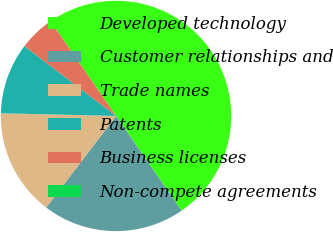<chart> <loc_0><loc_0><loc_500><loc_500><pie_chart><fcel>Developed technology<fcel>Customer relationships and<fcel>Trade names<fcel>Patents<fcel>Business licenses<fcel>Non-compete agreements<nl><fcel>49.99%<fcel>20.0%<fcel>15.0%<fcel>10.0%<fcel>5.0%<fcel>0.0%<nl></chart> 